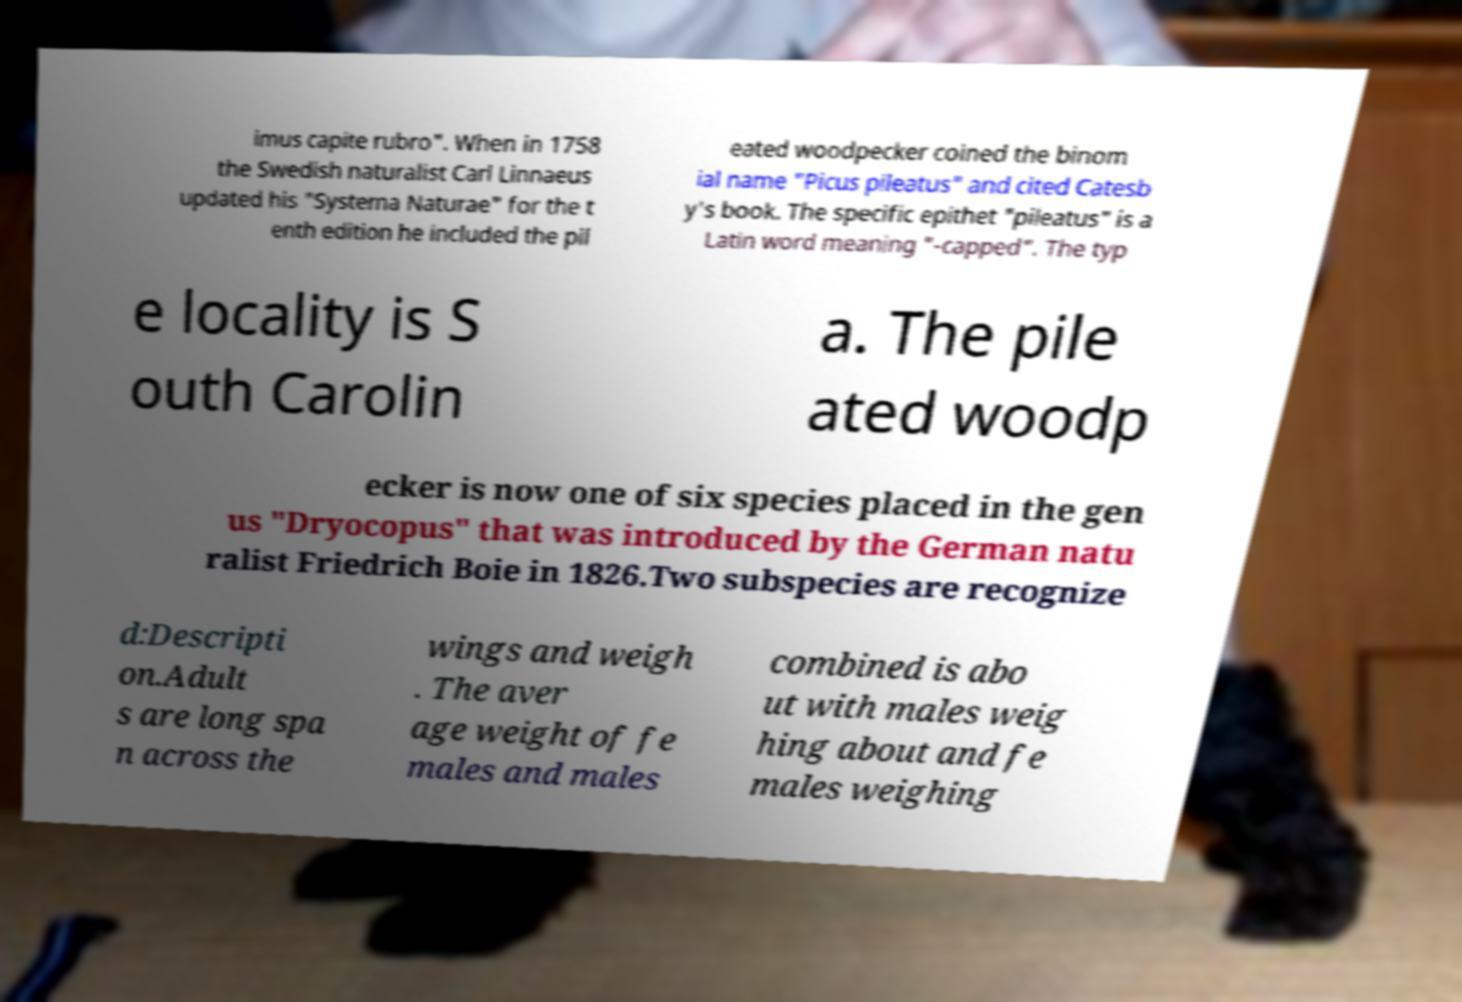Can you read and provide the text displayed in the image?This photo seems to have some interesting text. Can you extract and type it out for me? imus capite rubro". When in 1758 the Swedish naturalist Carl Linnaeus updated his "Systema Naturae" for the t enth edition he included the pil eated woodpecker coined the binom ial name "Picus pileatus" and cited Catesb y's book. The specific epithet "pileatus" is a Latin word meaning "-capped". The typ e locality is S outh Carolin a. The pile ated woodp ecker is now one of six species placed in the gen us "Dryocopus" that was introduced by the German natu ralist Friedrich Boie in 1826.Two subspecies are recognize d:Descripti on.Adult s are long spa n across the wings and weigh . The aver age weight of fe males and males combined is abo ut with males weig hing about and fe males weighing 